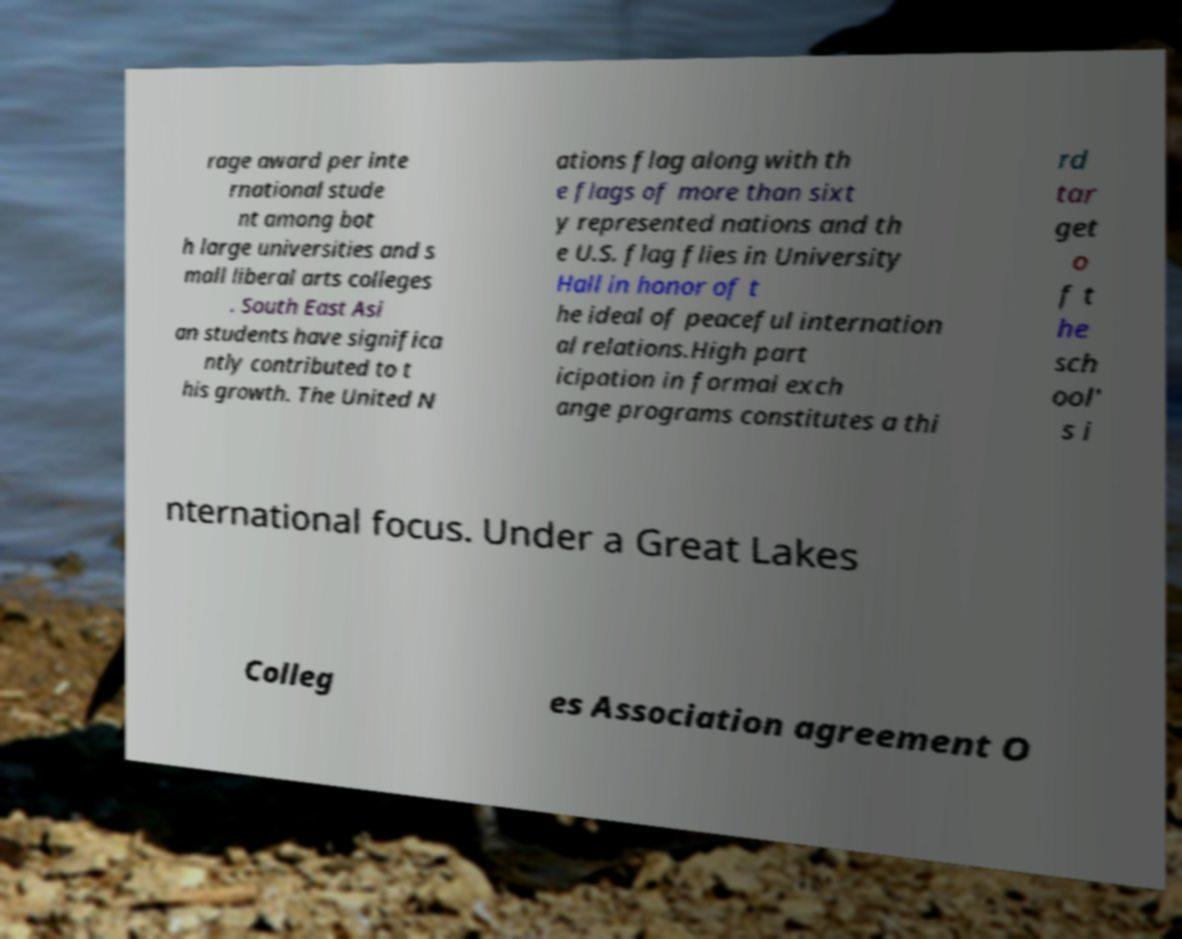Could you assist in decoding the text presented in this image and type it out clearly? rage award per inte rnational stude nt among bot h large universities and s mall liberal arts colleges . South East Asi an students have significa ntly contributed to t his growth. The United N ations flag along with th e flags of more than sixt y represented nations and th e U.S. flag flies in University Hall in honor of t he ideal of peaceful internation al relations.High part icipation in formal exch ange programs constitutes a thi rd tar get o f t he sch ool' s i nternational focus. Under a Great Lakes Colleg es Association agreement O 